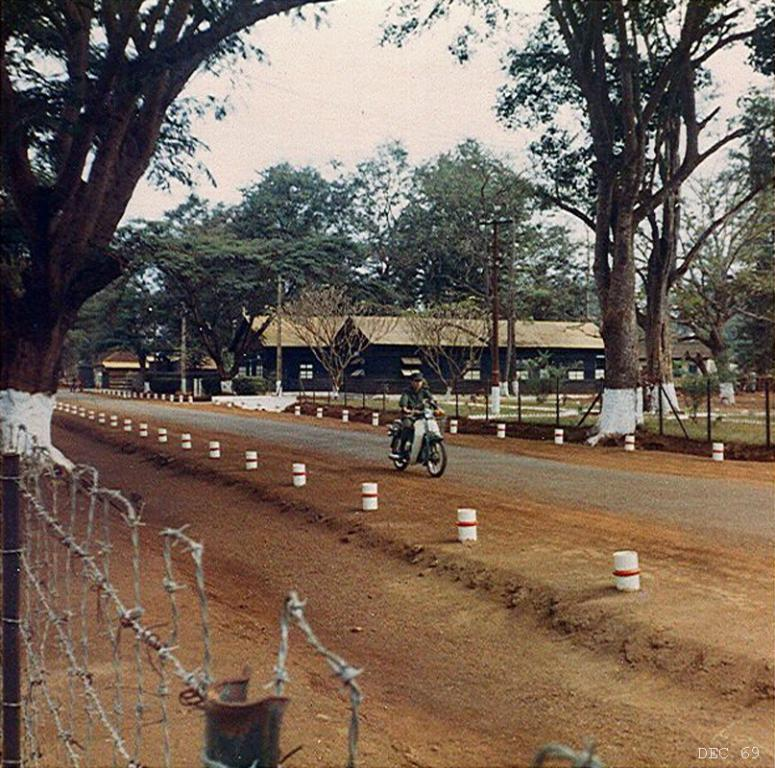What is the person in the image doing? The person is riding a bike in the image. Where is the bike located? The bike is on the road in the image. What can be seen in the background of the image? The sky is visible in the background of the image. What type of structures are present in the image? There are sheds in the image. What type of vegetation is present in the image? There are trees in the image. What type of barrier is present in the image? There is a fence in the image. What type of surface is visible in the image? The ground is visible in the image. What type of stamp can be seen on the person's shirt in the image? There is no stamp visible on the person's shirt in the image. What shape is the square that the person is pushing in the image? There is no square present in the image, nor is the person pushing anything. 